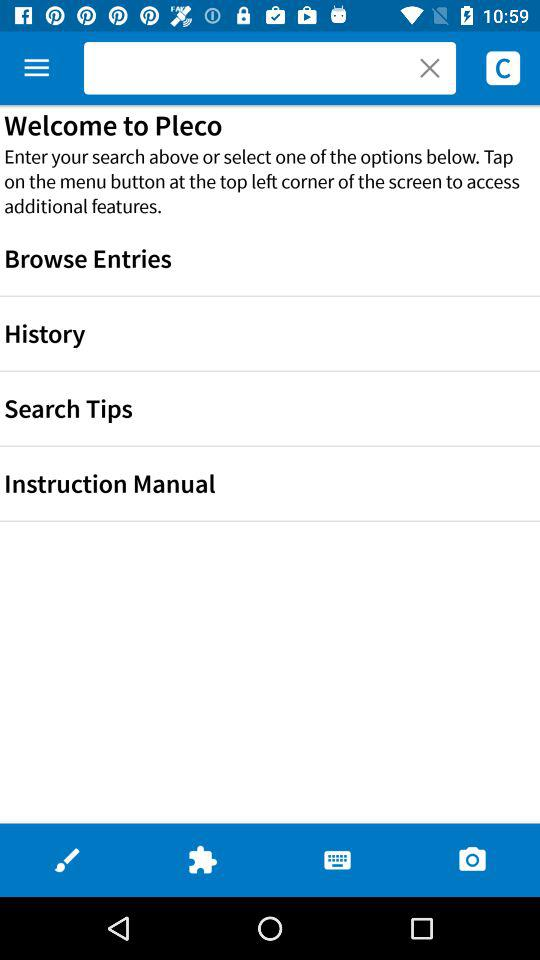What is the name of the application? The name of the application is "Pleco". 